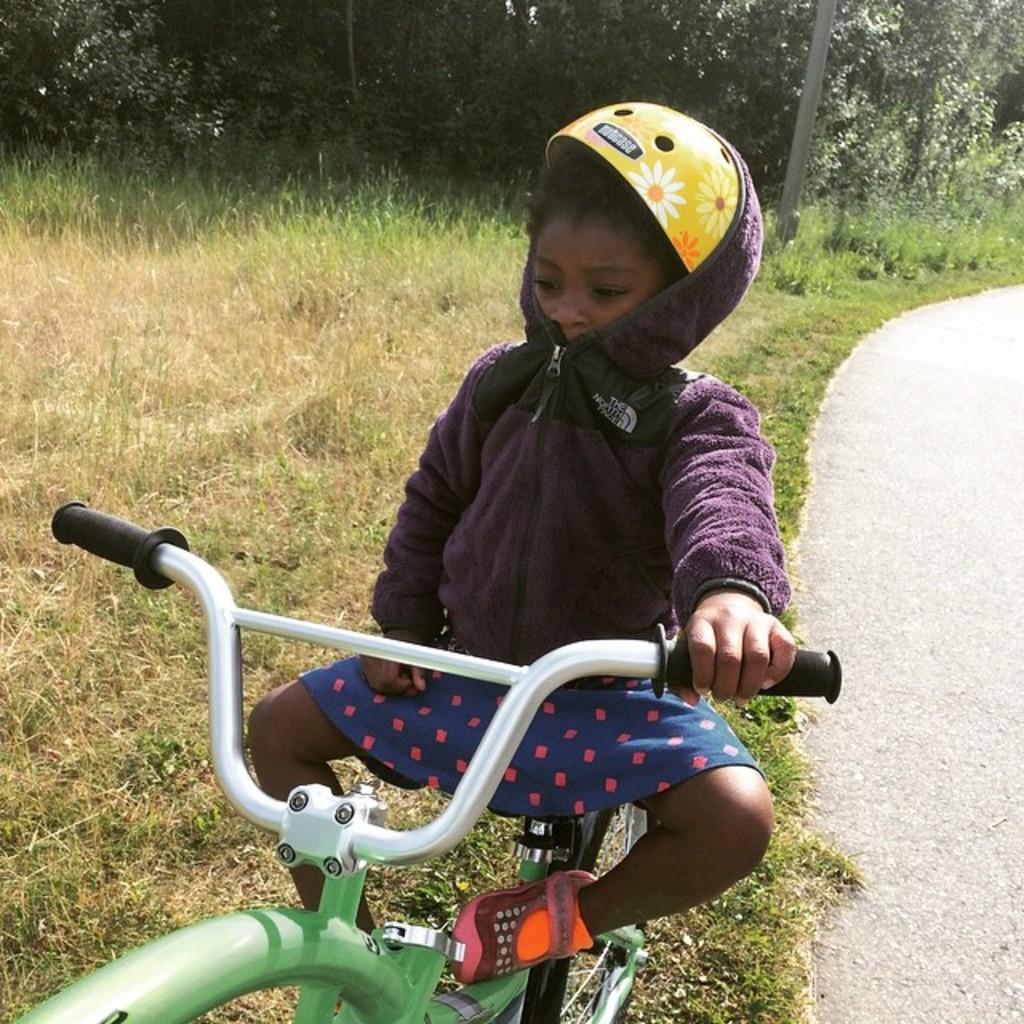How would you summarize this image in a sentence or two? This image is clicked outside. There is a cycle in the middle on which a boy is sitting. He is wearing helmet. There is grass in the bottom and there are trees on the top. There is Road on the right side. 